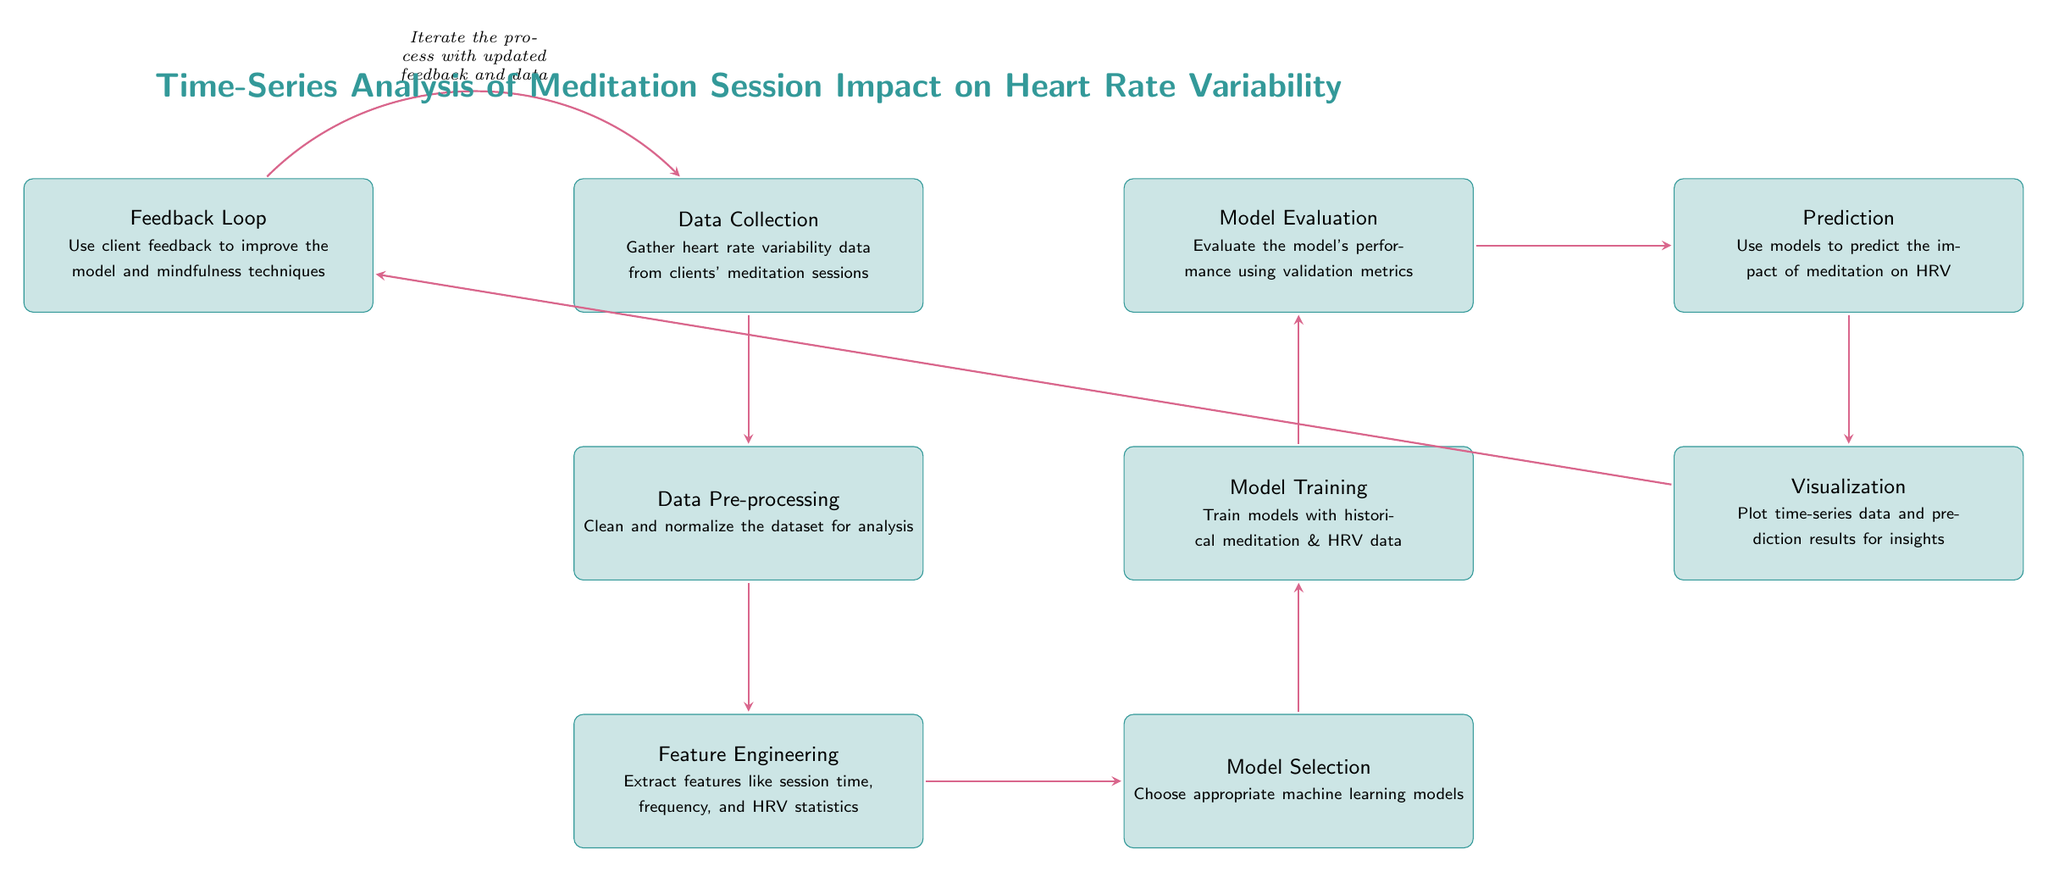What is the first step in the process? The first step in the diagram is "Data Collection," which involves gathering heart rate variability data from clients' meditation sessions.
Answer: Data Collection How many main process nodes are in the diagram? To determine the number of main process nodes, we can count the distinct boxes: Data Collection, Pre-Processing, Feature Engineering, Model Selection, Model Training, Evaluation, Prediction, Visualization, and Feedback Loop, giving a total of 9 nodes.
Answer: 9 Which node follows "Model Training"? The node that follows "Model Training" is "Evaluation." This indicates that after training the model, its performance is evaluated.
Answer: Evaluation What is the purpose of the "Feedback Loop"? The "Feedback Loop" is designed to use client feedback to improve the model and mindfulness techniques, thus ensuring continuous improvement based on real-world results.
Answer: Use client feedback Which step involves plotting data for insights? The step that involves plotting time-series data and prediction results for insights is "Visualization." This is crucial for interpreting the results visually.
Answer: Visualization How does the process iterate after the "Feedback Loop"? After the "Feedback Loop," the process iterates back to "Data Collection," indicating that updated feedback and data will lead to further collection of heart rate variability data.
Answer: Iterates to Data Collection What relationship exists between "Model Evaluation" and "Prediction"? The relationship is that "Model Evaluation" must occur before "Prediction"; this means that only after evaluating the model can predictions about meditation's impact on HRV be made.
Answer: Evaluation precedes Prediction What is the final output of the process? The final output of the process is the "Visualization," where insights from the predictions and data are presented visually for better understanding and analysis.
Answer: Visualization 